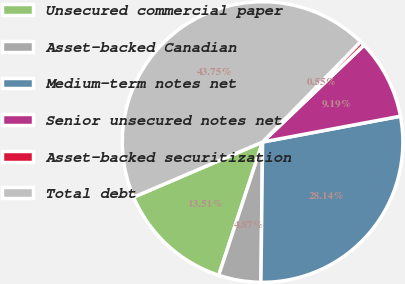<chart> <loc_0><loc_0><loc_500><loc_500><pie_chart><fcel>Unsecured commercial paper<fcel>Asset-backed Canadian<fcel>Medium-term notes net<fcel>Senior unsecured notes net<fcel>Asset-backed securitization<fcel>Total debt<nl><fcel>13.51%<fcel>4.87%<fcel>28.14%<fcel>9.19%<fcel>0.55%<fcel>43.75%<nl></chart> 